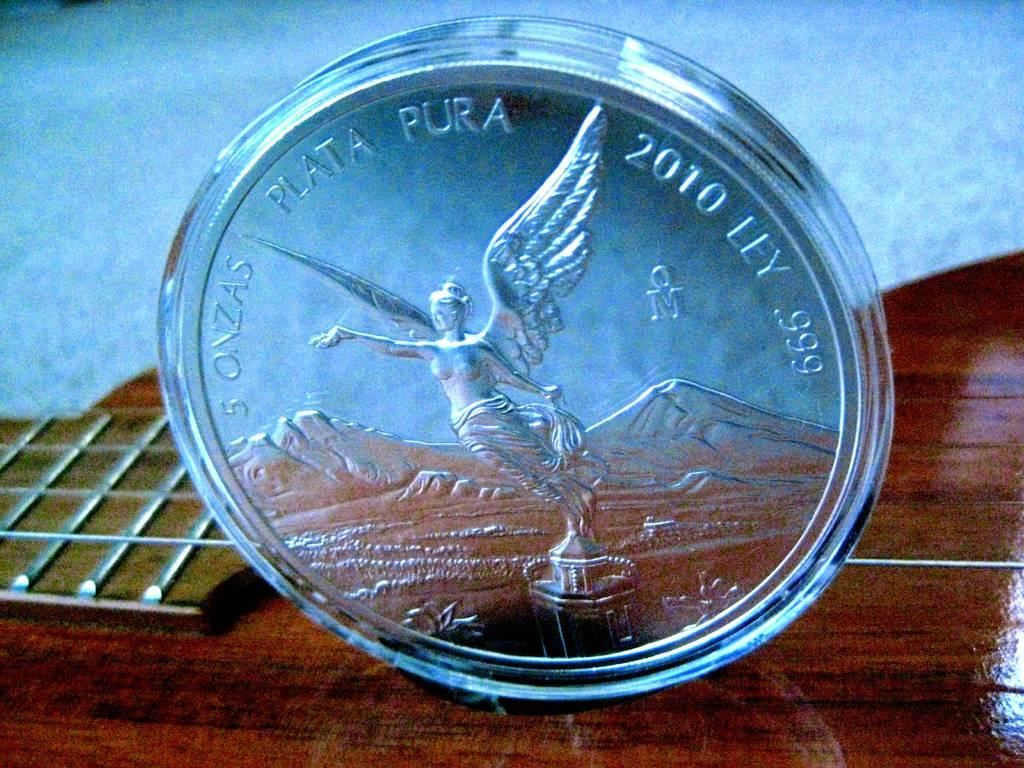<image>
Create a compact narrative representing the image presented. A coin with an angel from 2010 sits in a clear case on a wooden table. 